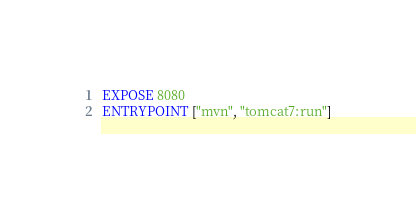Convert code to text. <code><loc_0><loc_0><loc_500><loc_500><_Dockerfile_>
EXPOSE 8080
ENTRYPOINT ["mvn", "tomcat7:run"]
</code> 